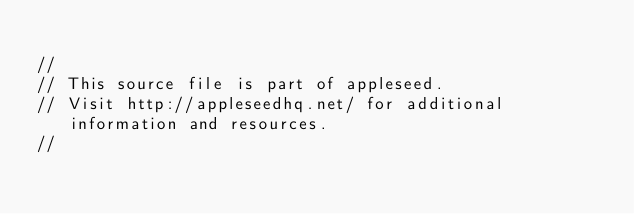<code> <loc_0><loc_0><loc_500><loc_500><_C++_>
//
// This source file is part of appleseed.
// Visit http://appleseedhq.net/ for additional information and resources.
//</code> 